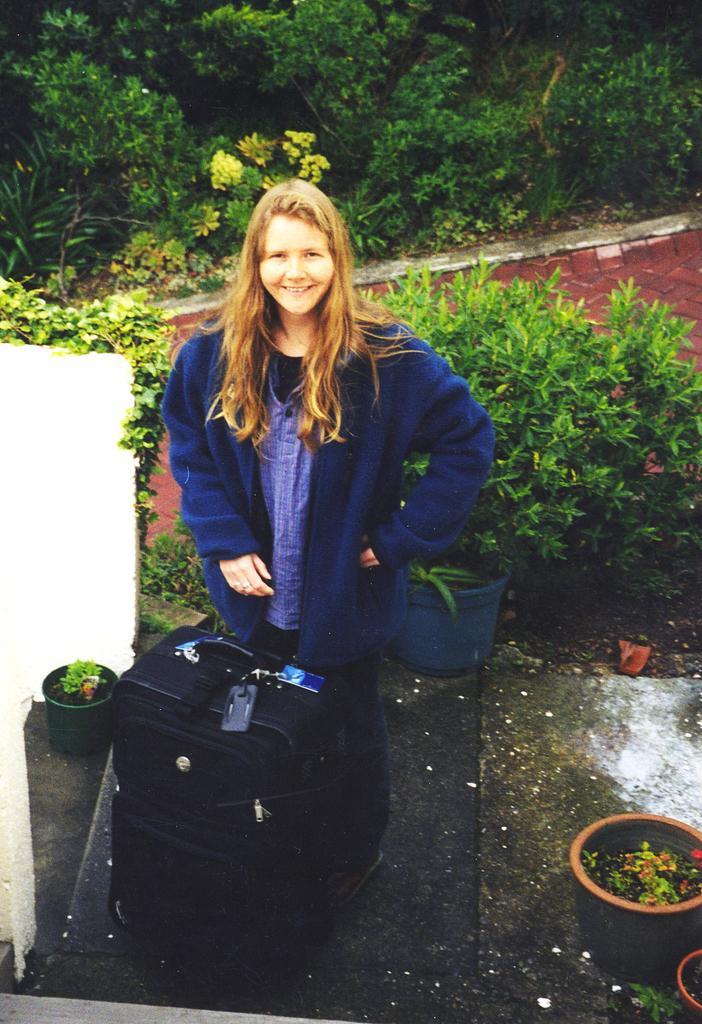Please provide a concise description of this image. In this image we can see a girl is standing. She is wearing blue color jacket. In front of her black color suitcase is present. Behind her plants and trees are there. Right bottom of the image pot is present. 